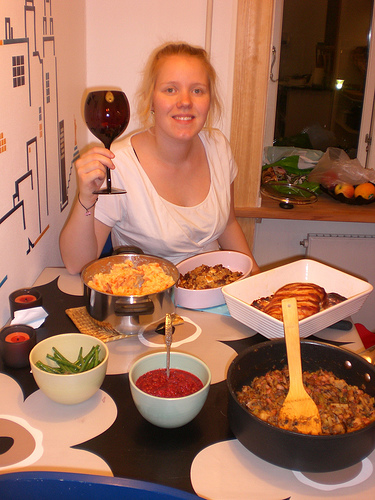<image>
Is there a food in the bowl? No. The food is not contained within the bowl. These objects have a different spatial relationship. Is there a spatula in the sauce? No. The spatula is not contained within the sauce. These objects have a different spatial relationship. Is there a food on the table? Yes. Looking at the image, I can see the food is positioned on top of the table, with the table providing support. 